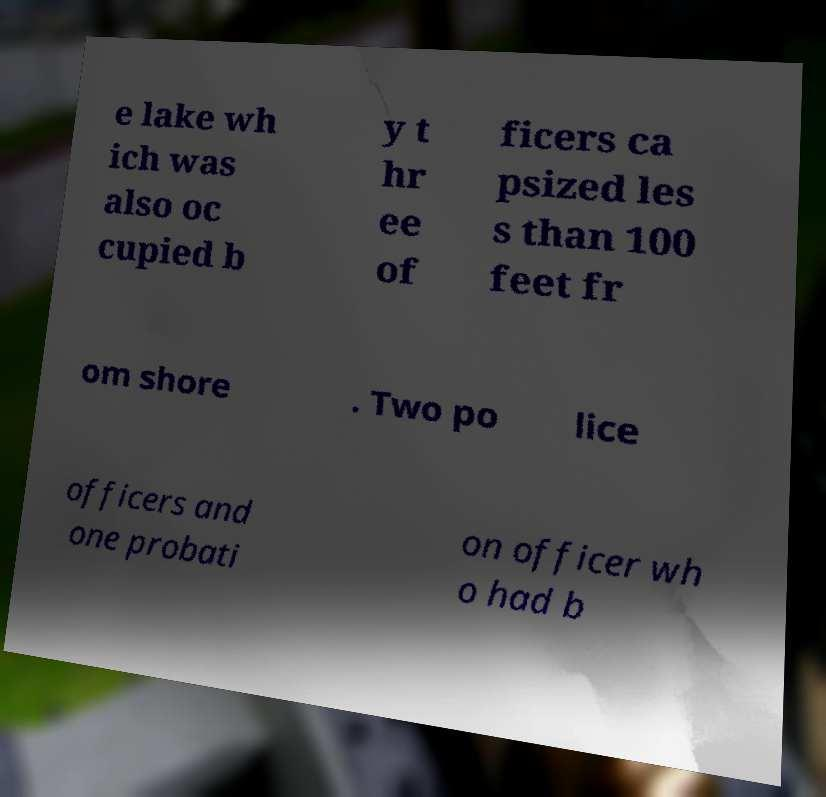I need the written content from this picture converted into text. Can you do that? e lake wh ich was also oc cupied b y t hr ee of ficers ca psized les s than 100 feet fr om shore . Two po lice officers and one probati on officer wh o had b 